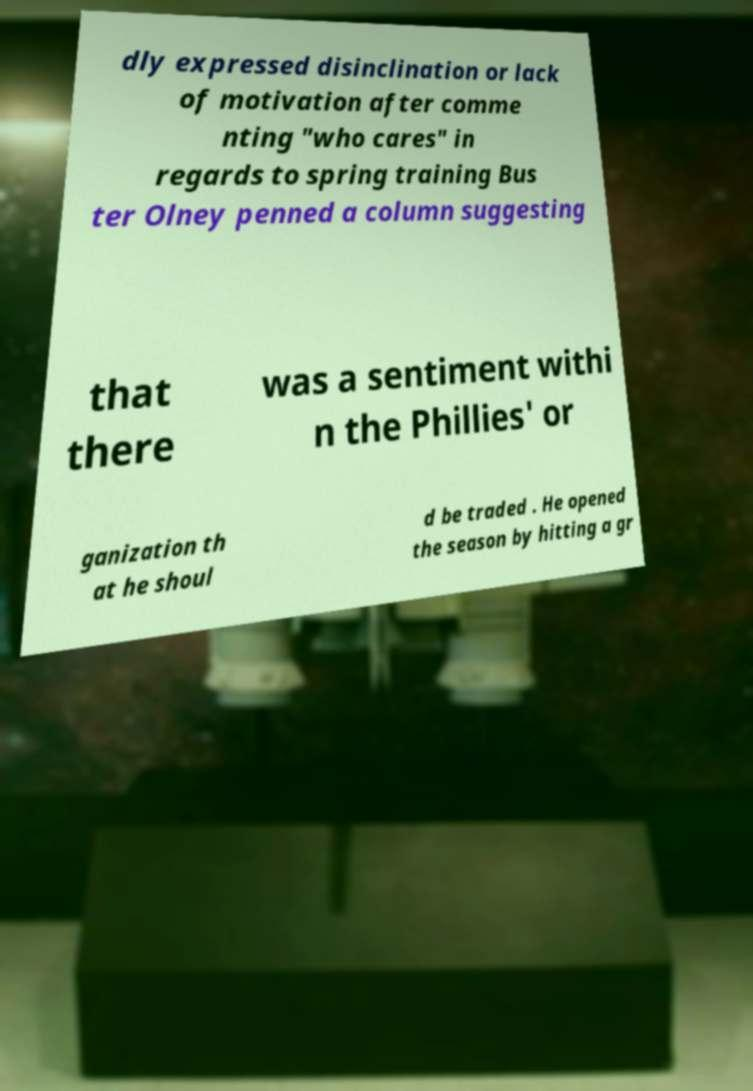There's text embedded in this image that I need extracted. Can you transcribe it verbatim? dly expressed disinclination or lack of motivation after comme nting "who cares" in regards to spring training Bus ter Olney penned a column suggesting that there was a sentiment withi n the Phillies' or ganization th at he shoul d be traded . He opened the season by hitting a gr 